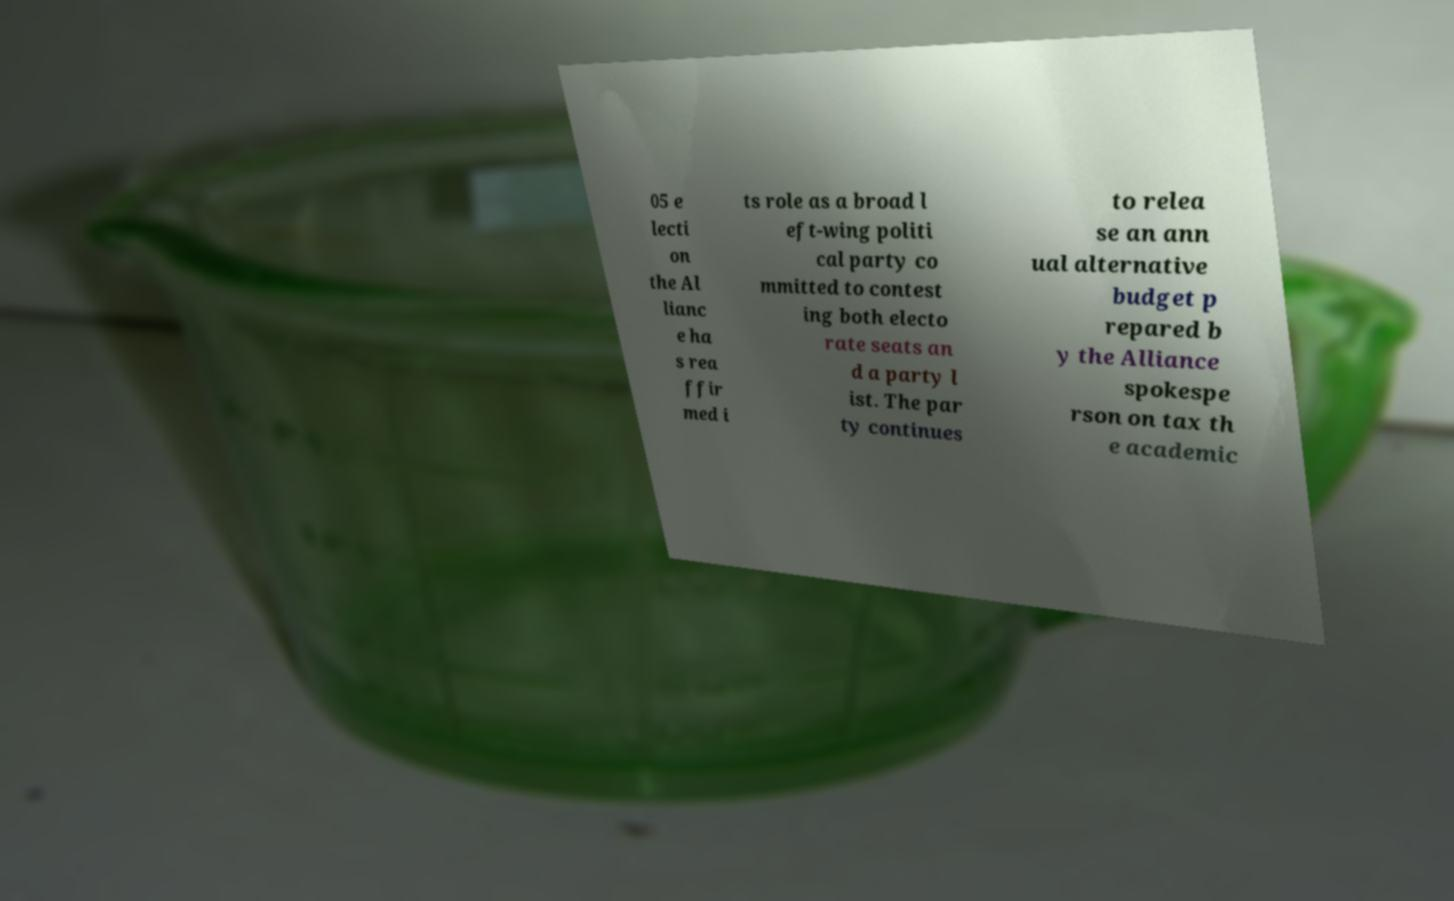Please identify and transcribe the text found in this image. 05 e lecti on the Al lianc e ha s rea ffir med i ts role as a broad l eft-wing politi cal party co mmitted to contest ing both electo rate seats an d a party l ist. The par ty continues to relea se an ann ual alternative budget p repared b y the Alliance spokespe rson on tax th e academic 